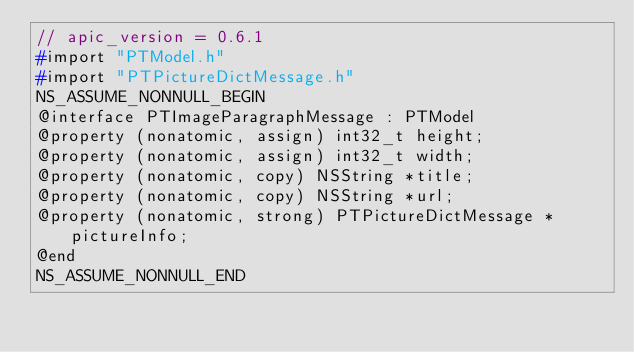<code> <loc_0><loc_0><loc_500><loc_500><_C_>// apic_version = 0.6.1
#import "PTModel.h"
#import "PTPictureDictMessage.h"
NS_ASSUME_NONNULL_BEGIN
@interface PTImageParagraphMessage : PTModel
@property (nonatomic, assign) int32_t height;
@property (nonatomic, assign) int32_t width;
@property (nonatomic, copy) NSString *title;
@property (nonatomic, copy) NSString *url;
@property (nonatomic, strong) PTPictureDictMessage *pictureInfo;
@end
NS_ASSUME_NONNULL_END
</code> 